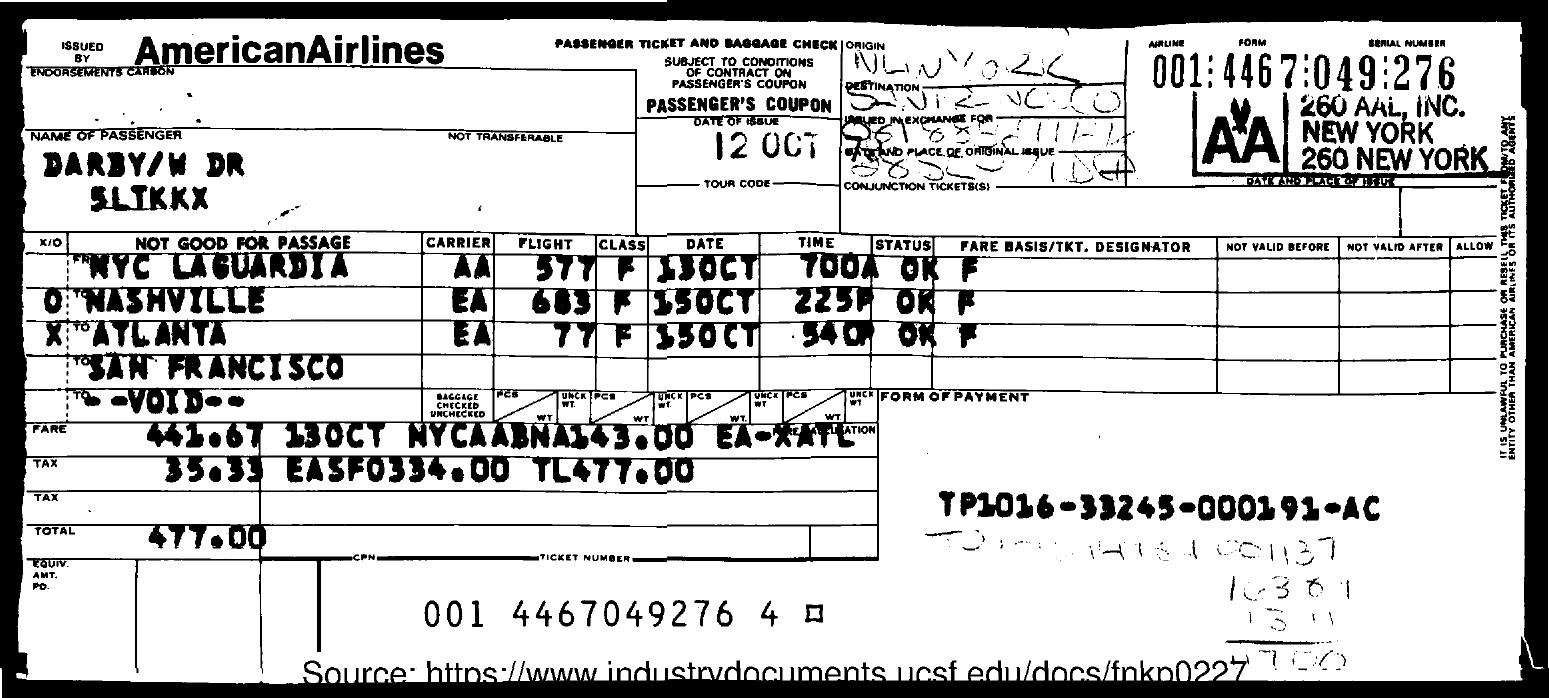Highlight a few significant elements in this photo. The date of issue is October 12th. The form of payment for transaction TP1016-33245-000191-AC is... The total is 477.00, rounded to the nearest dollar. The ticket number is 001 4467049276 4. 